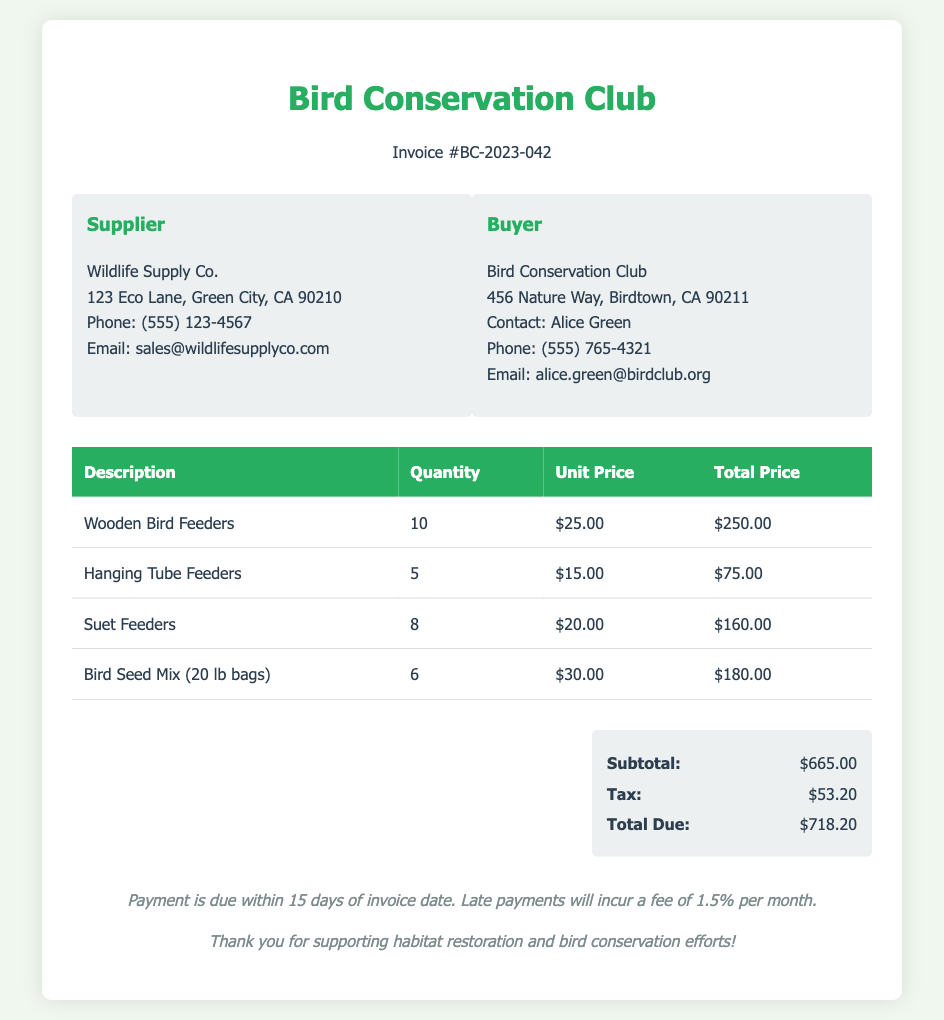what is the invoice number? The invoice number is listed at the top of the document as a unique identifier for this transaction.
Answer: BC-2023-042 who is the supplier? The document contains information about the supplier, including their name and contact details.
Answer: Wildlife Supply Co what is the total due amount? The total due is found in the summary section at the bottom of the invoice.
Answer: $718.20 how many Wooden Bird Feeders were ordered? The quantity of Wooden Bird Feeders is specified in the table listing the purchased items.
Answer: 10 what is the unit price of Hanging Tube Feeders? The unit price is provided in the same table as the quantities and total prices for each item.
Answer: $15.00 what is the subtotal before tax? The subtotal is indicated in the summary section as the total cost of the items before tax is applied.
Answer: $665.00 how many types of feeders are listed? The document lists various feeders with distinct descriptions in the item table.
Answer: 4 what is the tax amount? The tax amount is specified in the summary section of the invoice.
Answer: $53.20 what is the address of the buyer? The buyer's address is provided in their information box, which includes details about the Bird Conservation Club.
Answer: 456 Nature Way, Birdtown, CA 90211 